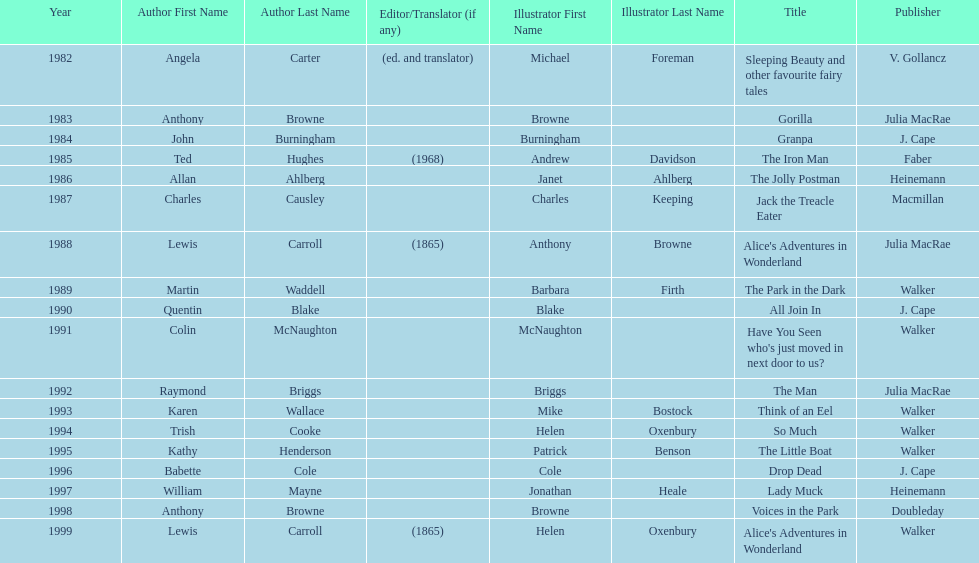How many titles did walker publish? 6. 